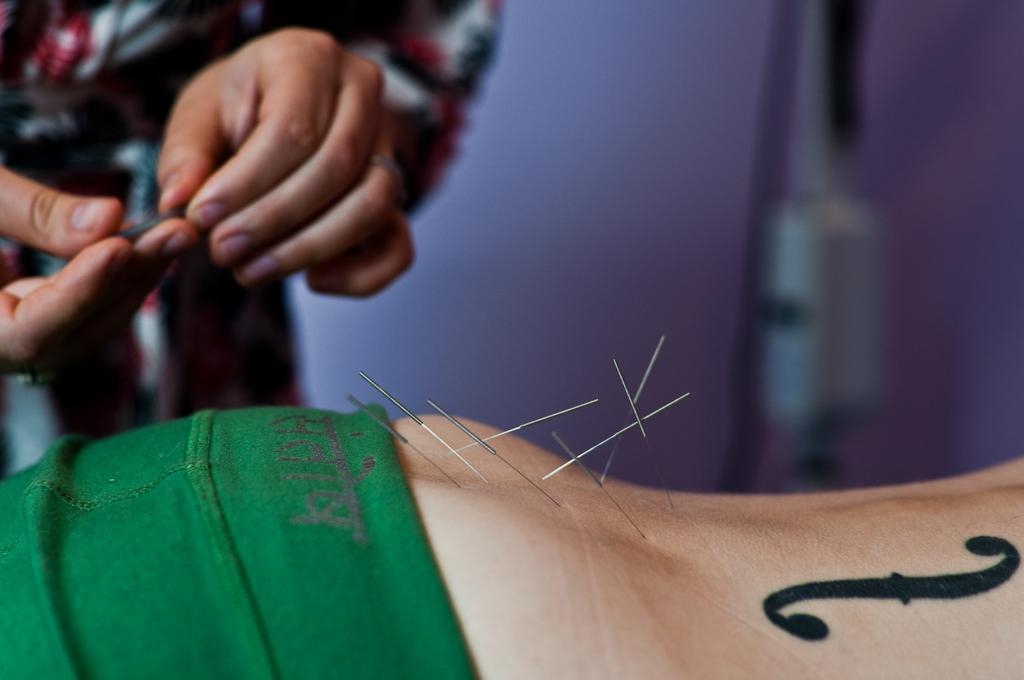What is the main subject of the image? There is a human standing in the image. What is the standing human holding in their hands? The standing human is holding needles in their hands. What is happening to another human's body in the image? There are needles pierced into another human's body. What can be seen in the background of the image? There is a wall visible in the background of the image. What type of bait is being used to catch fish in the image? There is no mention of fishing or bait in the image; it features a human holding needles and another human with needles pierced into their body. How is the string being used in the image? There is no string present in the image. 